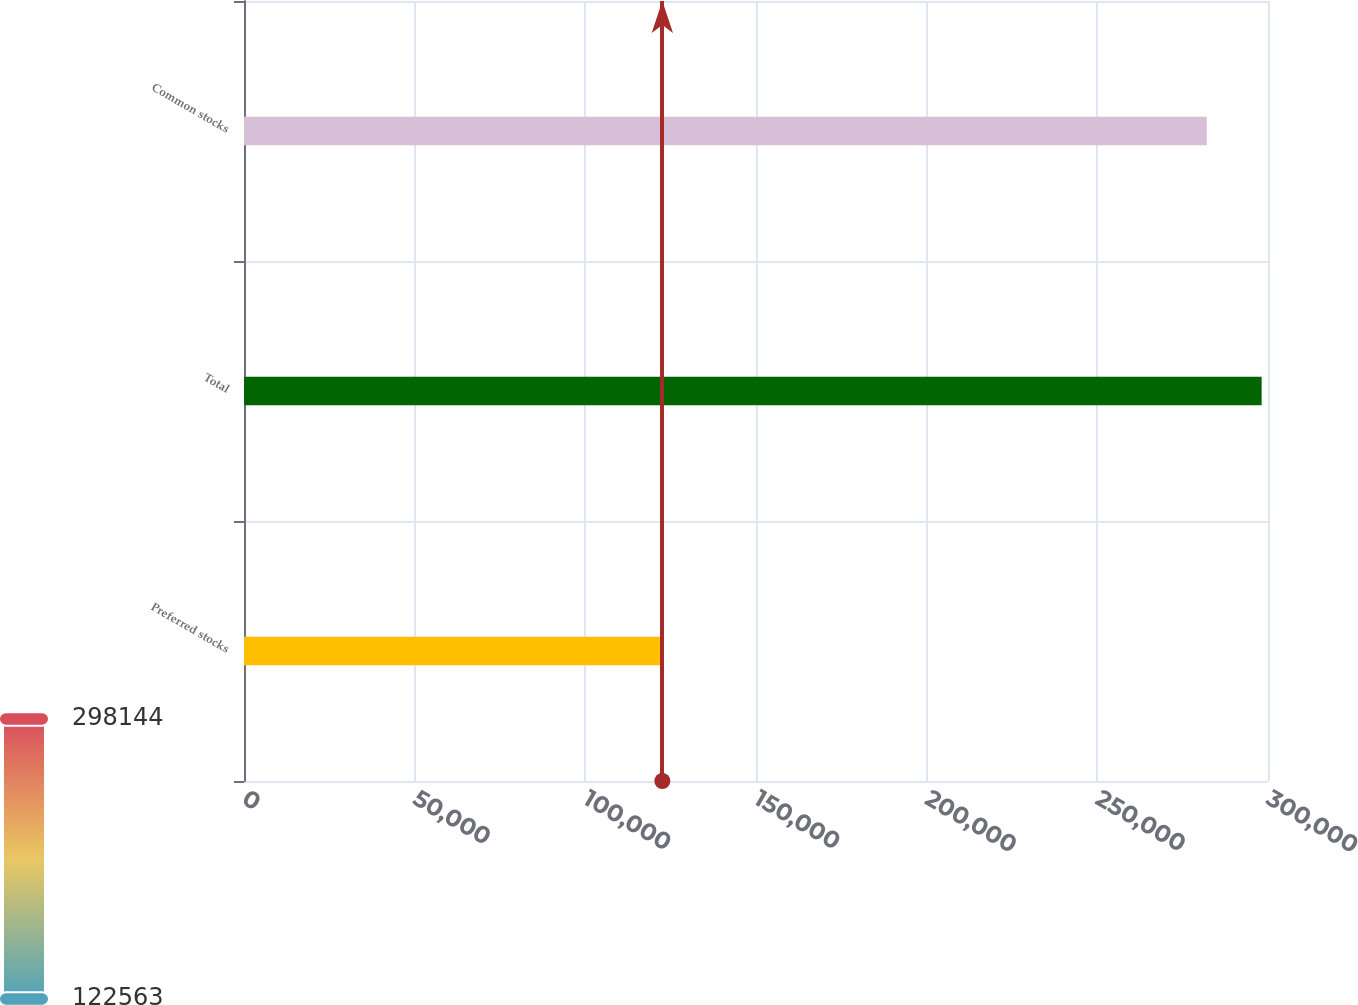Convert chart. <chart><loc_0><loc_0><loc_500><loc_500><bar_chart><fcel>Preferred stocks<fcel>Total<fcel>Common stocks<nl><fcel>122563<fcel>298144<fcel>282066<nl></chart> 